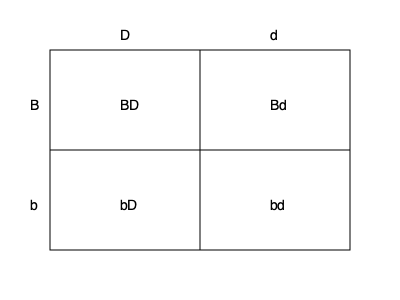In a breeding program for Labrador Retrievers, you're working with coat color genes. The gene for black coat (B) is dominant to brown (b), and the gene for non-dilute color (D) is dominant to dilute (d). If you breed two dogs that are both heterozygous for both traits (BbDd), what percentage of their puppies would be expected to have a black, non-dilute coat? To solve this problem, we need to use a Punnett square and follow these steps:

1. Identify the genotypes of the parent dogs:
   Both parents are heterozygous for both traits (BbDd)

2. Set up the Punnett square:
   - One parent's alleles (BD, Bd, bD, bd) along the top
   - The other parent's alleles (BD, Bd, bD, bd) along the left side

3. Fill in the Punnett square by combining the alleles:
   This results in 16 possible genotype combinations

4. Identify the genotypes that result in black, non-dilute coat:
   Any genotype with at least one B and one D will have this phenotype
   
5. Count the number of black, non-dilute genotypes:
   BBDD, BBDd, BbDD, BbDd (9 out of 16 combinations)

6. Calculate the percentage:
   $\frac{9}{16} \times 100\% = 56.25\%$

Therefore, 56.25% of the puppies are expected to have a black, non-dilute coat.
Answer: 56.25% 